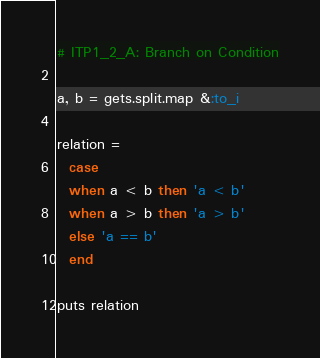<code> <loc_0><loc_0><loc_500><loc_500><_Ruby_># ITP1_2_A: Branch on Condition

a, b = gets.split.map &:to_i

relation =
  case
  when a < b then 'a < b'
  when a > b then 'a > b'
  else 'a == b'
  end

puts relation</code> 